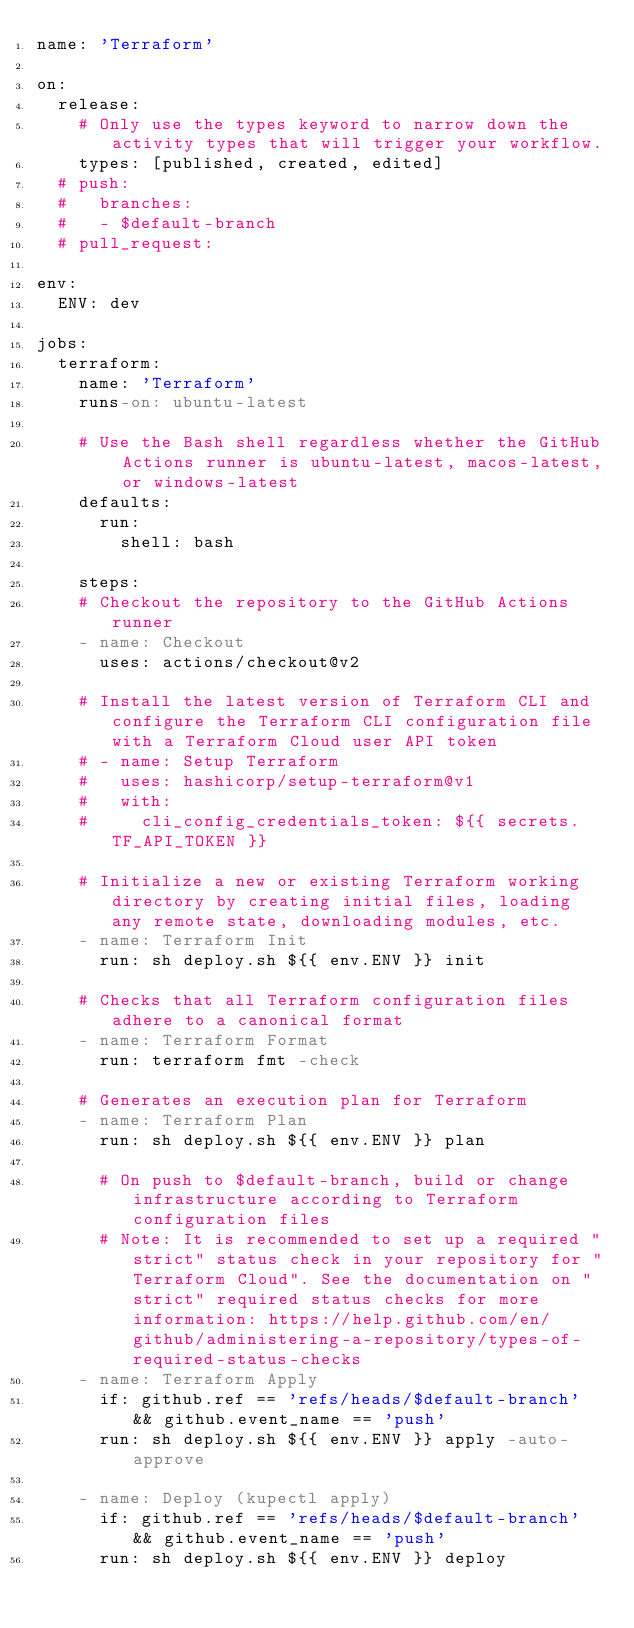<code> <loc_0><loc_0><loc_500><loc_500><_YAML_>name: 'Terraform'

on:
  release:
    # Only use the types keyword to narrow down the activity types that will trigger your workflow.
    types: [published, created, edited]
  # push:
  #   branches:
  #   - $default-branch
  # pull_request:

env:
  ENV: dev

jobs:
  terraform:
    name: 'Terraform'
    runs-on: ubuntu-latest

    # Use the Bash shell regardless whether the GitHub Actions runner is ubuntu-latest, macos-latest, or windows-latest
    defaults:
      run:
        shell: bash

    steps:
    # Checkout the repository to the GitHub Actions runner
    - name: Checkout
      uses: actions/checkout@v2

    # Install the latest version of Terraform CLI and configure the Terraform CLI configuration file with a Terraform Cloud user API token
    # - name: Setup Terraform
    #   uses: hashicorp/setup-terraform@v1
    #   with:
    #     cli_config_credentials_token: ${{ secrets.TF_API_TOKEN }}

    # Initialize a new or existing Terraform working directory by creating initial files, loading any remote state, downloading modules, etc.
    - name: Terraform Init
      run: sh deploy.sh ${{ env.ENV }} init

    # Checks that all Terraform configuration files adhere to a canonical format
    - name: Terraform Format
      run: terraform fmt -check

    # Generates an execution plan for Terraform
    - name: Terraform Plan
      run: sh deploy.sh ${{ env.ENV }} plan

      # On push to $default-branch, build or change infrastructure according to Terraform configuration files
      # Note: It is recommended to set up a required "strict" status check in your repository for "Terraform Cloud". See the documentation on "strict" required status checks for more information: https://help.github.com/en/github/administering-a-repository/types-of-required-status-checks
    - name: Terraform Apply
      if: github.ref == 'refs/heads/$default-branch' && github.event_name == 'push'
      run: sh deploy.sh ${{ env.ENV }} apply -auto-approve

    - name: Deploy (kupectl apply)
      if: github.ref == 'refs/heads/$default-branch' && github.event_name == 'push'
      run: sh deploy.sh ${{ env.ENV }} deploy</code> 